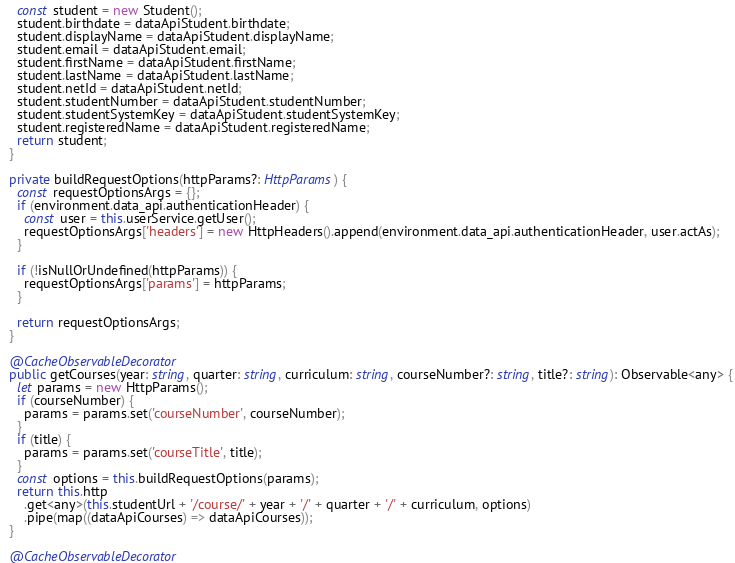Convert code to text. <code><loc_0><loc_0><loc_500><loc_500><_TypeScript_>    const student = new Student();
    student.birthdate = dataApiStudent.birthdate;
    student.displayName = dataApiStudent.displayName;
    student.email = dataApiStudent.email;
    student.firstName = dataApiStudent.firstName;
    student.lastName = dataApiStudent.lastName;
    student.netId = dataApiStudent.netId;
    student.studentNumber = dataApiStudent.studentNumber;
    student.studentSystemKey = dataApiStudent.studentSystemKey;
    student.registeredName = dataApiStudent.registeredName;
    return student;
  }

  private buildRequestOptions(httpParams?: HttpParams) {
    const requestOptionsArgs = {};
    if (environment.data_api.authenticationHeader) {
      const user = this.userService.getUser();
      requestOptionsArgs['headers'] = new HttpHeaders().append(environment.data_api.authenticationHeader, user.actAs);
    }

    if (!isNullOrUndefined(httpParams)) {
      requestOptionsArgs['params'] = httpParams;
    }

    return requestOptionsArgs;
  }

  @CacheObservableDecorator
  public getCourses(year: string, quarter: string, curriculum: string, courseNumber?: string, title?: string): Observable<any> {
    let params = new HttpParams();
    if (courseNumber) {
      params = params.set('courseNumber', courseNumber);
    }
    if (title) {
      params = params.set('courseTitle', title);
    }
    const options = this.buildRequestOptions(params);
    return this.http
      .get<any>(this.studentUrl + '/course/' + year + '/' + quarter + '/' + curriculum, options)
      .pipe(map((dataApiCourses) => dataApiCourses));
  }

  @CacheObservableDecorator</code> 